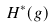<formula> <loc_0><loc_0><loc_500><loc_500>H ^ { * } ( g )</formula> 